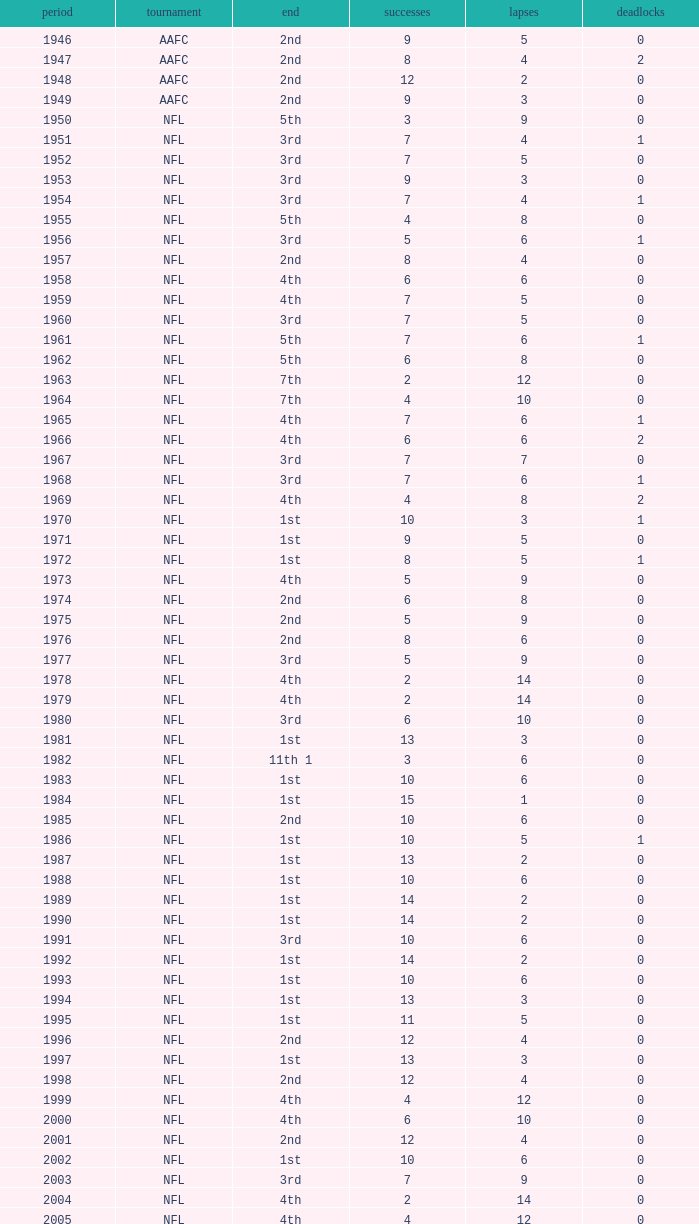What is the lowest number of ties in the NFL, with less than 2 losses and less than 15 wins? None. 